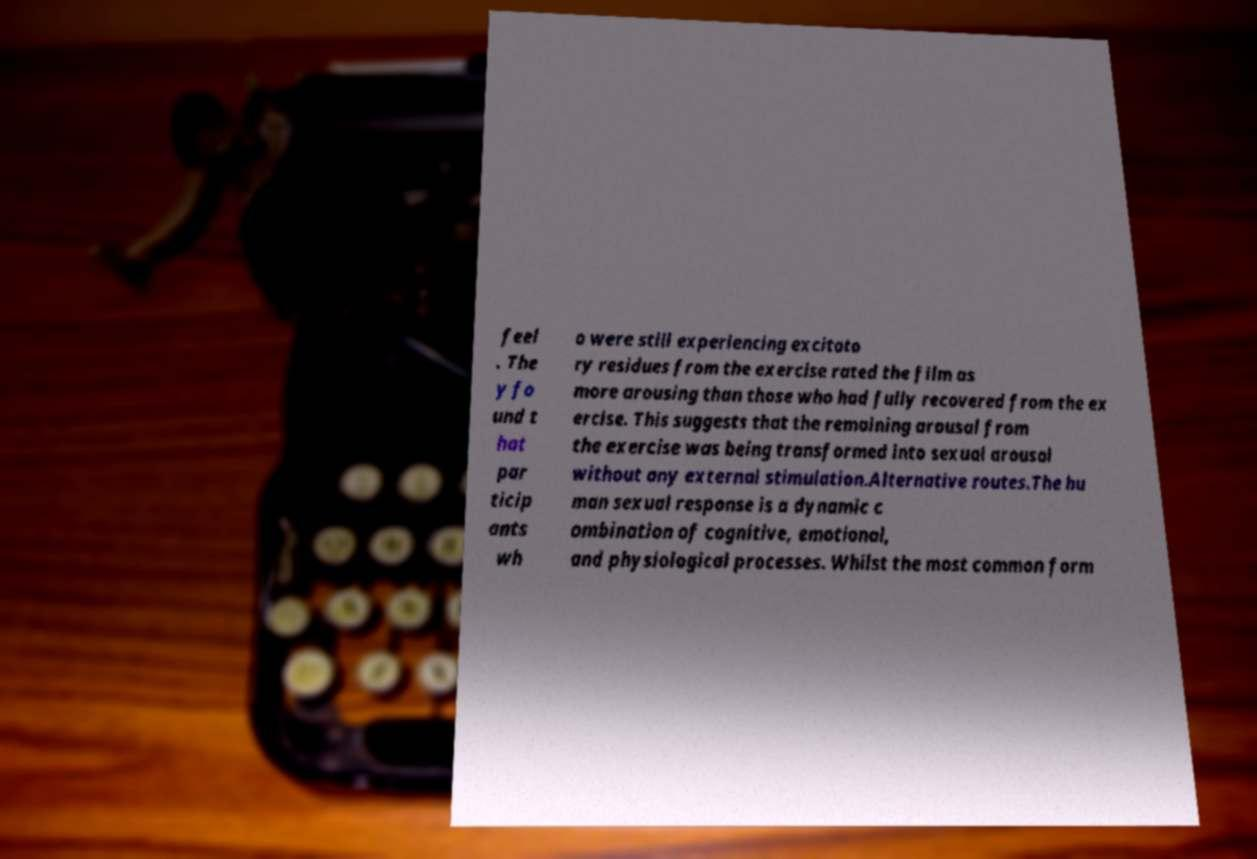Could you extract and type out the text from this image? feel . The y fo und t hat par ticip ants wh o were still experiencing excitato ry residues from the exercise rated the film as more arousing than those who had fully recovered from the ex ercise. This suggests that the remaining arousal from the exercise was being transformed into sexual arousal without any external stimulation.Alternative routes.The hu man sexual response is a dynamic c ombination of cognitive, emotional, and physiological processes. Whilst the most common form 